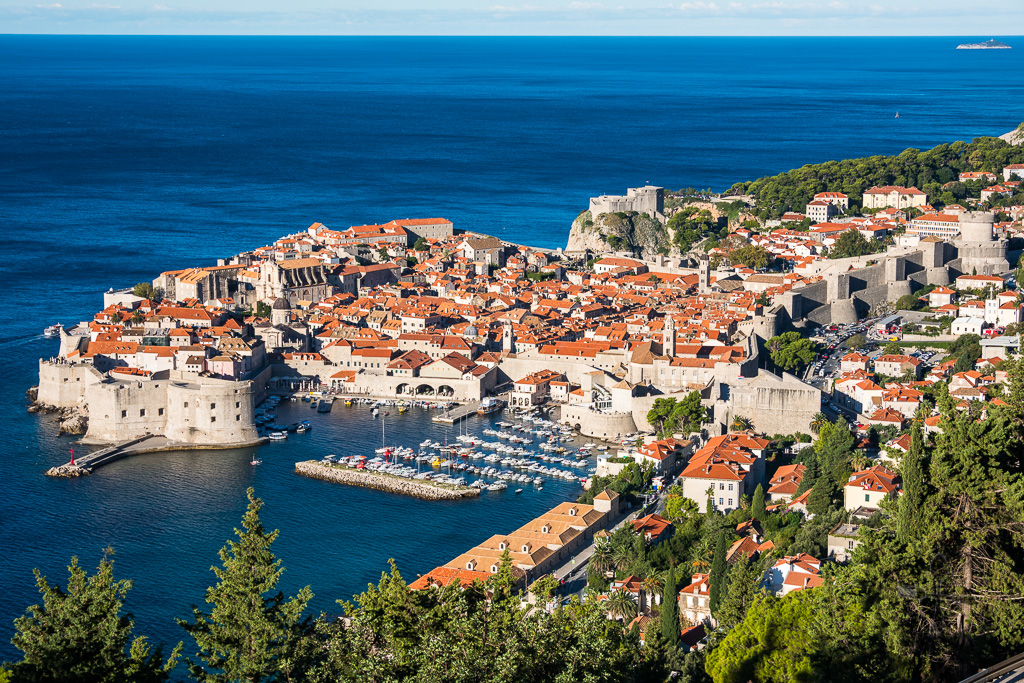Imagine a fantastic scenario where time travelers visit Dubrovnik's city walls. What historical period would they choose to stay in? Imagine time travelers arriving in Dubrovnik with a choice of historical periods to explore. They might choose to stay in the 15th century, during the golden age of the Republic of Ragusa. At this time, Dubrovnik was a flourishing maritime republic, renowned for its diplomacy, trade, and culture. The city was a bustling hub of commerce, with merchants from all over the Mediterranean and beyond bringing goods, news, and culture. The Renaissance was just beginning to influence the city, leading to a blossoming of arts and architecture. Walking through the streets, time travelers would witness the construction of significant buildings like the Rector’s Palace and Sponza Palace, attend vibrant markets, and experience the sophisticated society that valued education, law, and international relations. This period would offer a rich tapestry of historical, cultural, and social experiences, making it an enthralling time to visit. 